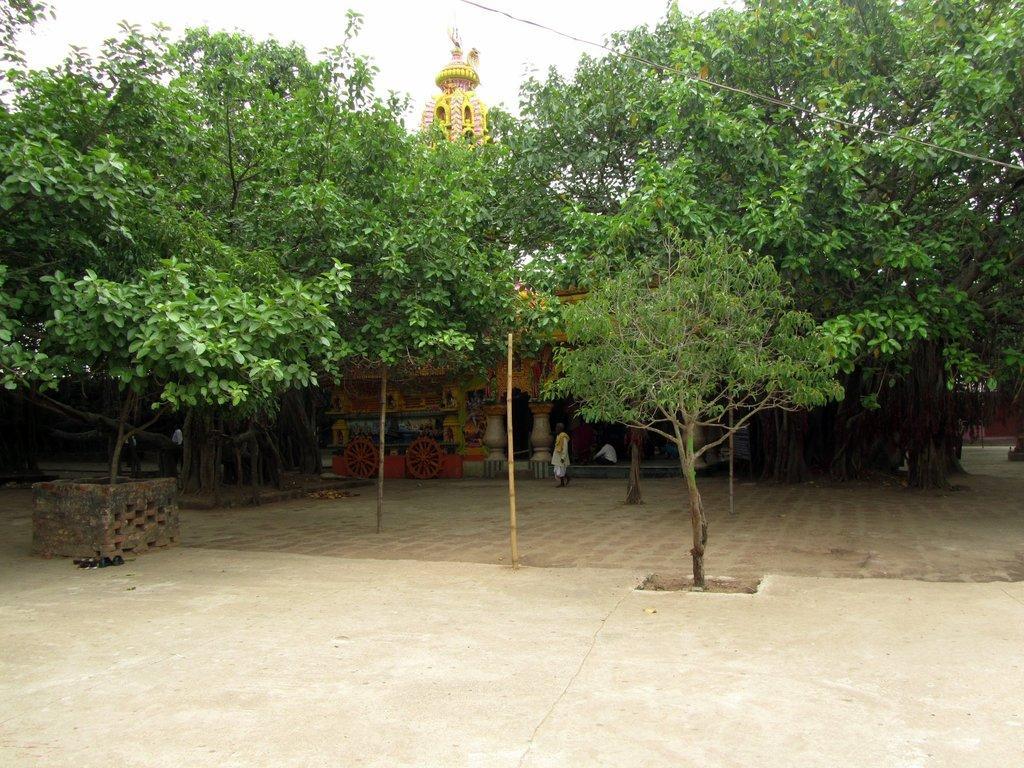Can you describe this image briefly? There is empty land in the foreground area of the image, there are trees, people, it seems like building structure and the sky in the background. 